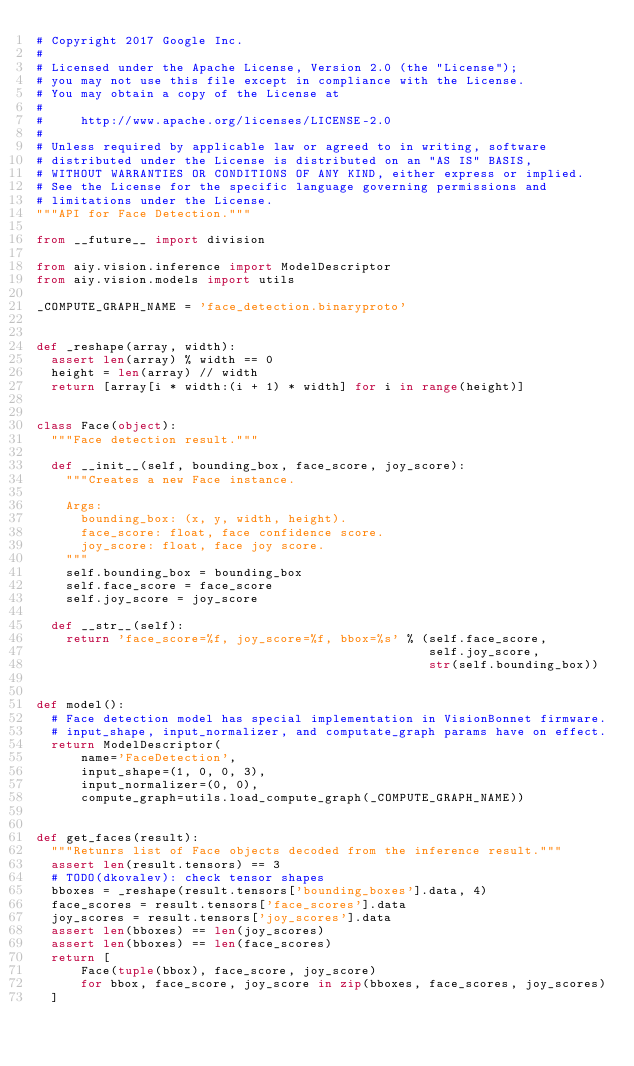Convert code to text. <code><loc_0><loc_0><loc_500><loc_500><_Python_># Copyright 2017 Google Inc.
#
# Licensed under the Apache License, Version 2.0 (the "License");
# you may not use this file except in compliance with the License.
# You may obtain a copy of the License at
#
#     http://www.apache.org/licenses/LICENSE-2.0
#
# Unless required by applicable law or agreed to in writing, software
# distributed under the License is distributed on an "AS IS" BASIS,
# WITHOUT WARRANTIES OR CONDITIONS OF ANY KIND, either express or implied.
# See the License for the specific language governing permissions and
# limitations under the License.
"""API for Face Detection."""

from __future__ import division

from aiy.vision.inference import ModelDescriptor
from aiy.vision.models import utils

_COMPUTE_GRAPH_NAME = 'face_detection.binaryproto'


def _reshape(array, width):
  assert len(array) % width == 0
  height = len(array) // width
  return [array[i * width:(i + 1) * width] for i in range(height)]


class Face(object):
  """Face detection result."""

  def __init__(self, bounding_box, face_score, joy_score):
    """Creates a new Face instance.

    Args:
      bounding_box: (x, y, width, height).
      face_score: float, face confidence score.
      joy_score: float, face joy score.
    """
    self.bounding_box = bounding_box
    self.face_score = face_score
    self.joy_score = joy_score

  def __str__(self):
    return 'face_score=%f, joy_score=%f, bbox=%s' % (self.face_score,
                                                     self.joy_score,
                                                     str(self.bounding_box))


def model():
  # Face detection model has special implementation in VisionBonnet firmware.
  # input_shape, input_normalizer, and computate_graph params have on effect.
  return ModelDescriptor(
      name='FaceDetection',
      input_shape=(1, 0, 0, 3),
      input_normalizer=(0, 0),
      compute_graph=utils.load_compute_graph(_COMPUTE_GRAPH_NAME))


def get_faces(result):
  """Retunrs list of Face objects decoded from the inference result."""
  assert len(result.tensors) == 3
  # TODO(dkovalev): check tensor shapes
  bboxes = _reshape(result.tensors['bounding_boxes'].data, 4)
  face_scores = result.tensors['face_scores'].data
  joy_scores = result.tensors['joy_scores'].data
  assert len(bboxes) == len(joy_scores)
  assert len(bboxes) == len(face_scores)
  return [
      Face(tuple(bbox), face_score, joy_score)
      for bbox, face_score, joy_score in zip(bboxes, face_scores, joy_scores)
  ]
</code> 